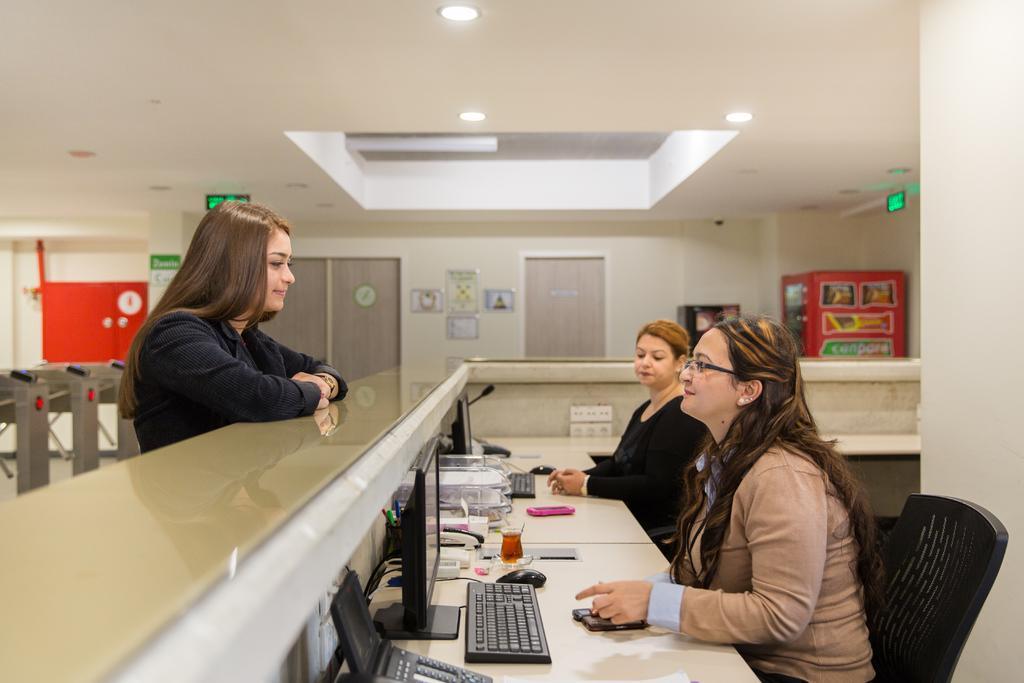In one or two sentences, can you explain what this image depicts? In this image we can see people sitting on the chairs and one person is standing in front of them, on the desk, we can see some objects like systems, mouse, keyboards, mobiles and other, on the top of the roof, we can see a some lights and direction boards, there are some photo frames on the wall and a clock on the wardrobe. 